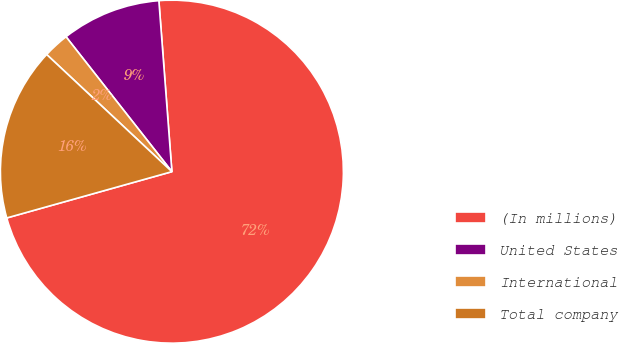Convert chart to OTSL. <chart><loc_0><loc_0><loc_500><loc_500><pie_chart><fcel>(In millions)<fcel>United States<fcel>International<fcel>Total company<nl><fcel>71.86%<fcel>9.38%<fcel>2.44%<fcel>16.32%<nl></chart> 